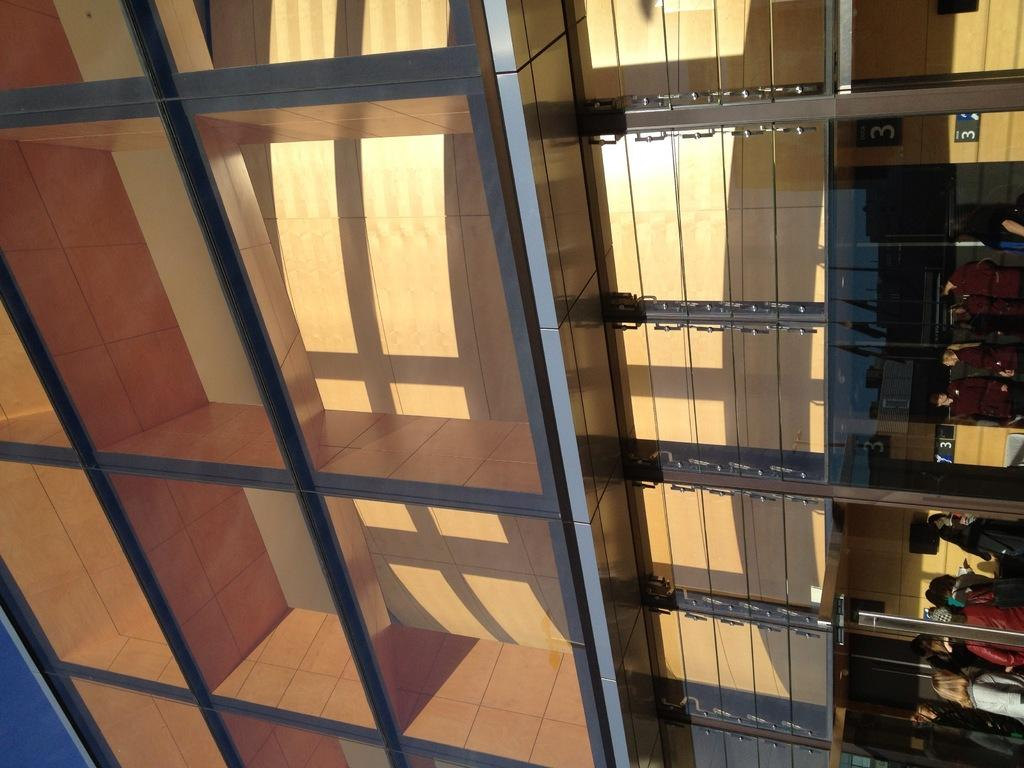<image>
Write a terse but informative summary of the picture. A sideways view of a building front with rows of glass and wood that is numbered 3 in the top right. 